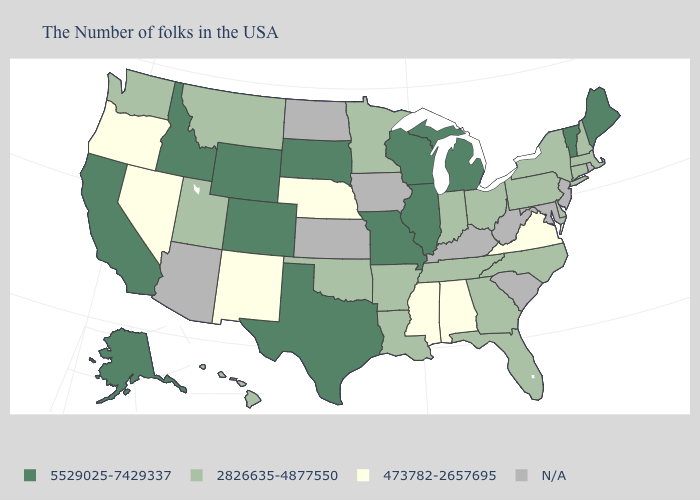What is the lowest value in the USA?
Keep it brief. 473782-2657695. What is the lowest value in the USA?
Quick response, please. 473782-2657695. Which states have the lowest value in the USA?
Write a very short answer. Virginia, Alabama, Mississippi, Nebraska, New Mexico, Nevada, Oregon. Name the states that have a value in the range 2826635-4877550?
Quick response, please. Massachusetts, New Hampshire, Connecticut, New York, Delaware, Pennsylvania, North Carolina, Ohio, Florida, Georgia, Indiana, Tennessee, Louisiana, Arkansas, Minnesota, Oklahoma, Utah, Montana, Washington, Hawaii. What is the lowest value in states that border Pennsylvania?
Concise answer only. 2826635-4877550. What is the lowest value in the USA?
Give a very brief answer. 473782-2657695. Does the first symbol in the legend represent the smallest category?
Write a very short answer. No. Does the first symbol in the legend represent the smallest category?
Be succinct. No. What is the highest value in the West ?
Write a very short answer. 5529025-7429337. Does Minnesota have the highest value in the USA?
Give a very brief answer. No. What is the highest value in the West ?
Answer briefly. 5529025-7429337. Name the states that have a value in the range 473782-2657695?
Keep it brief. Virginia, Alabama, Mississippi, Nebraska, New Mexico, Nevada, Oregon. 